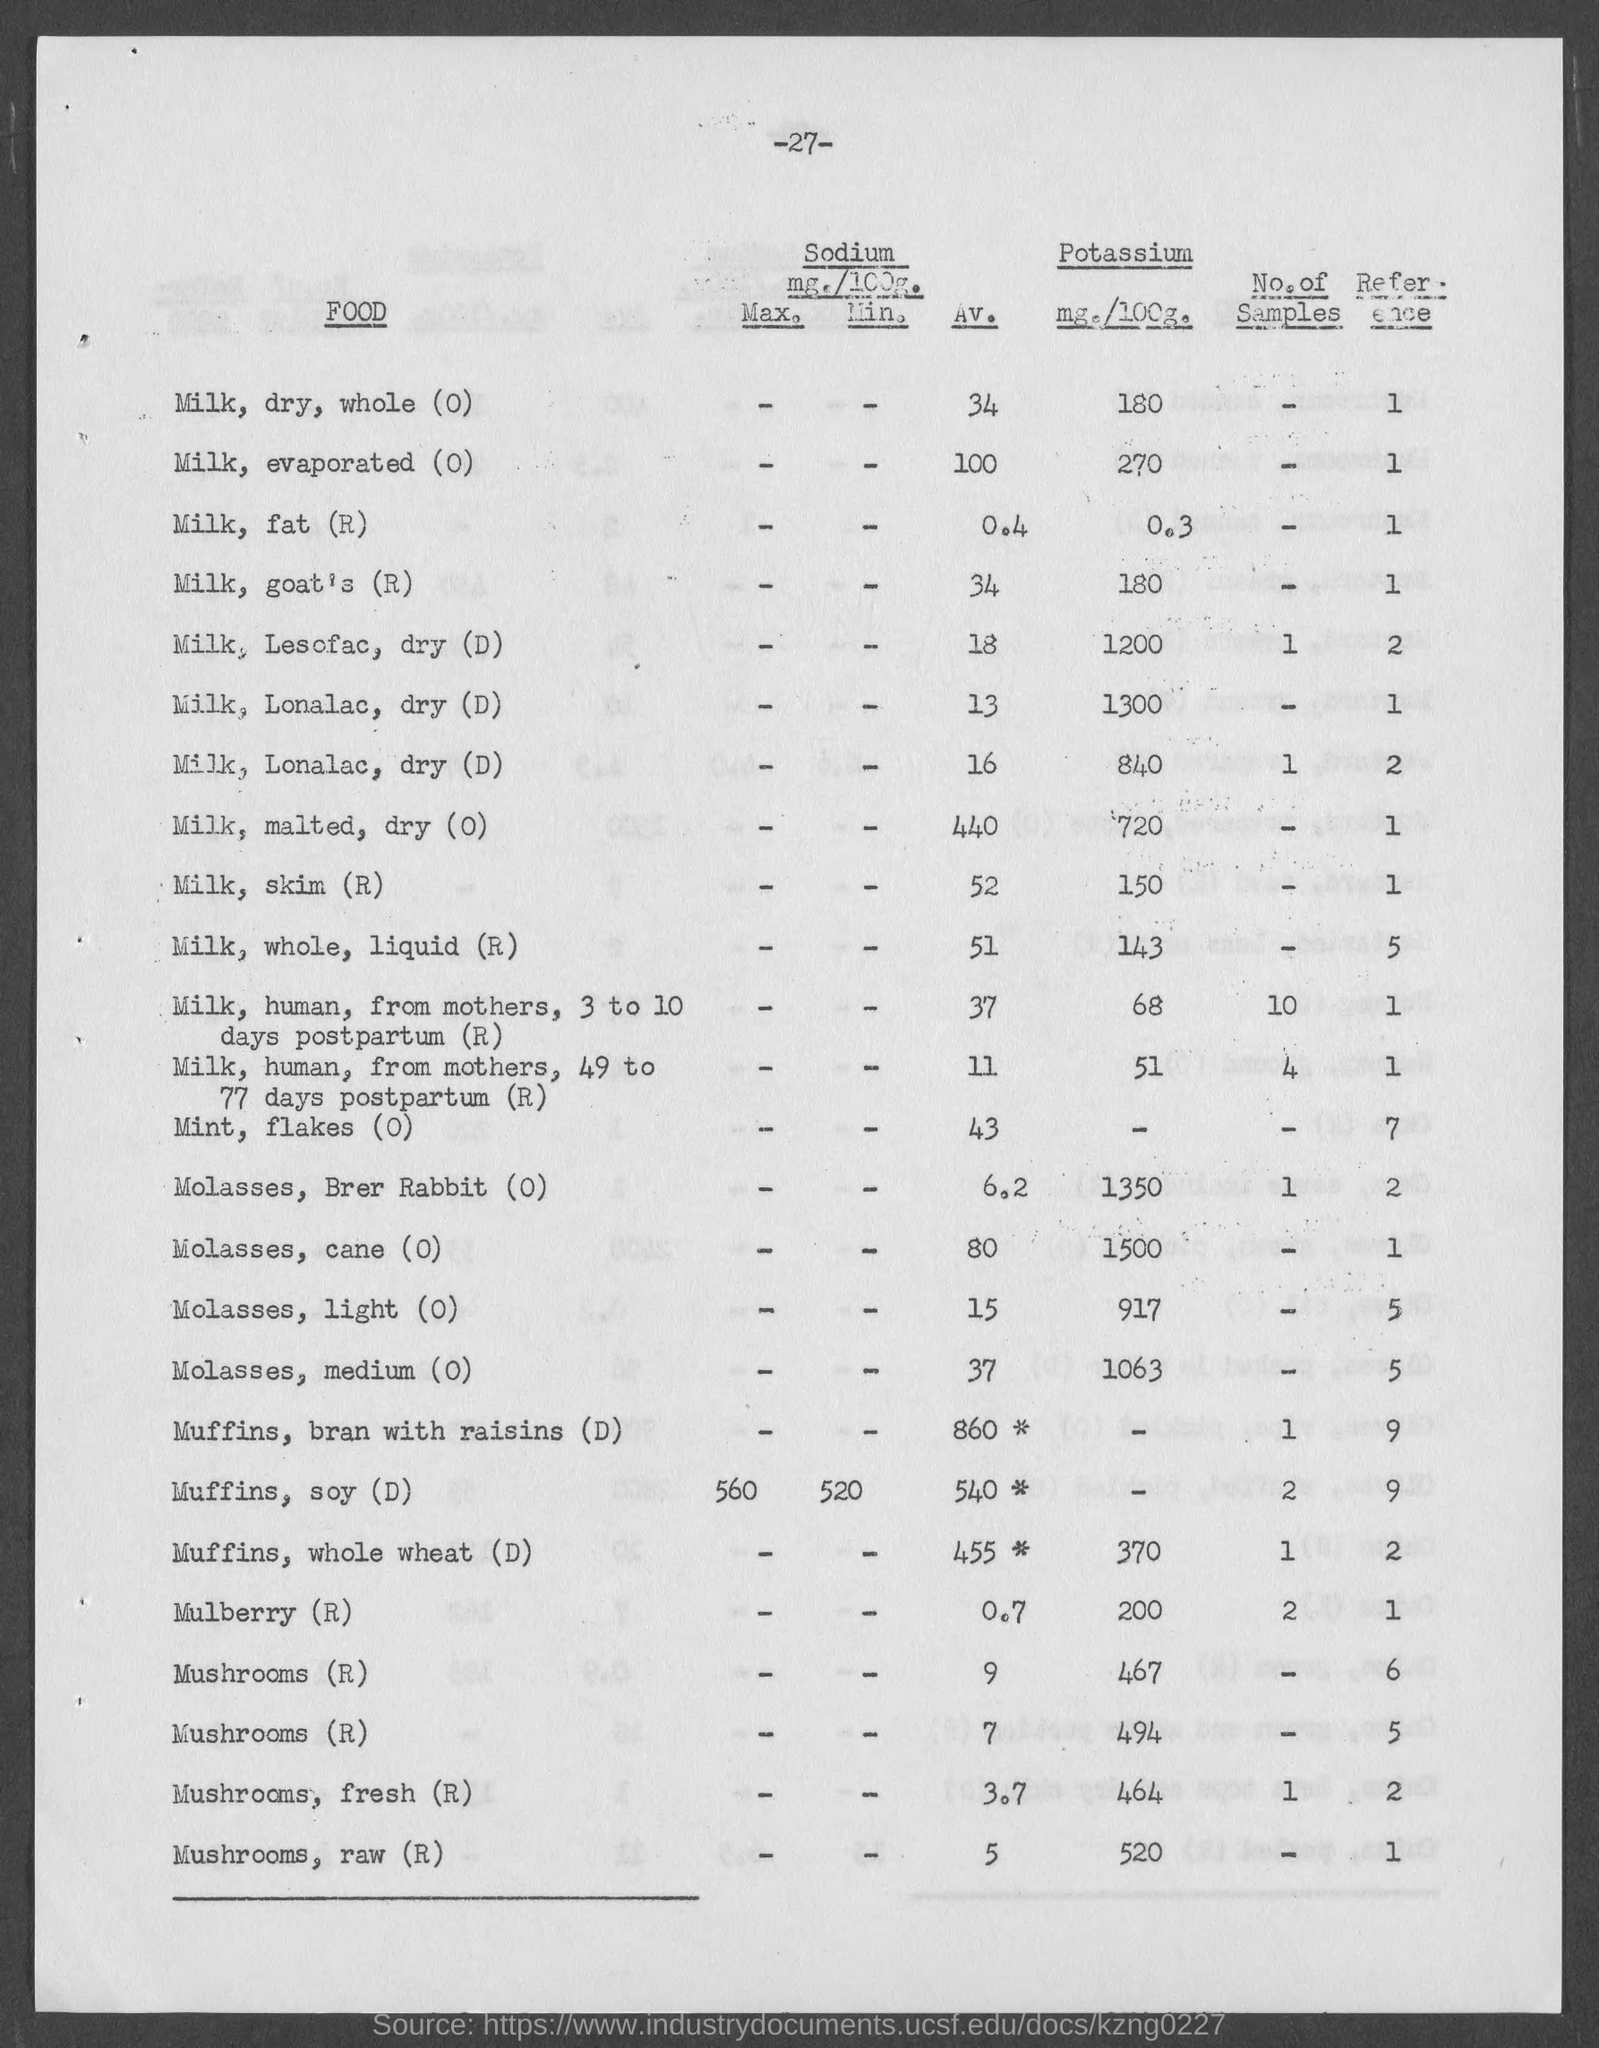Point out several critical features in this image. The number of samples of soy muffins is 2. The number of samples of Mushrooms, fresh (R) is 1. The page number is -27-. 